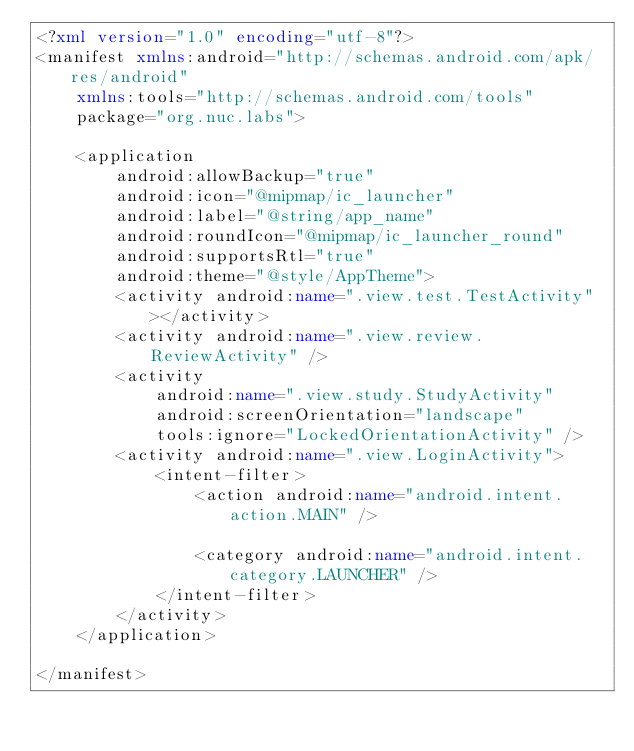Convert code to text. <code><loc_0><loc_0><loc_500><loc_500><_XML_><?xml version="1.0" encoding="utf-8"?>
<manifest xmlns:android="http://schemas.android.com/apk/res/android"
    xmlns:tools="http://schemas.android.com/tools"
    package="org.nuc.labs">

    <application
        android:allowBackup="true"
        android:icon="@mipmap/ic_launcher"
        android:label="@string/app_name"
        android:roundIcon="@mipmap/ic_launcher_round"
        android:supportsRtl="true"
        android:theme="@style/AppTheme">
        <activity android:name=".view.test.TestActivity"></activity>
        <activity android:name=".view.review.ReviewActivity" />
        <activity
            android:name=".view.study.StudyActivity"
            android:screenOrientation="landscape"
            tools:ignore="LockedOrientationActivity" />
        <activity android:name=".view.LoginActivity">
            <intent-filter>
                <action android:name="android.intent.action.MAIN" />

                <category android:name="android.intent.category.LAUNCHER" />
            </intent-filter>
        </activity>
    </application>

</manifest></code> 